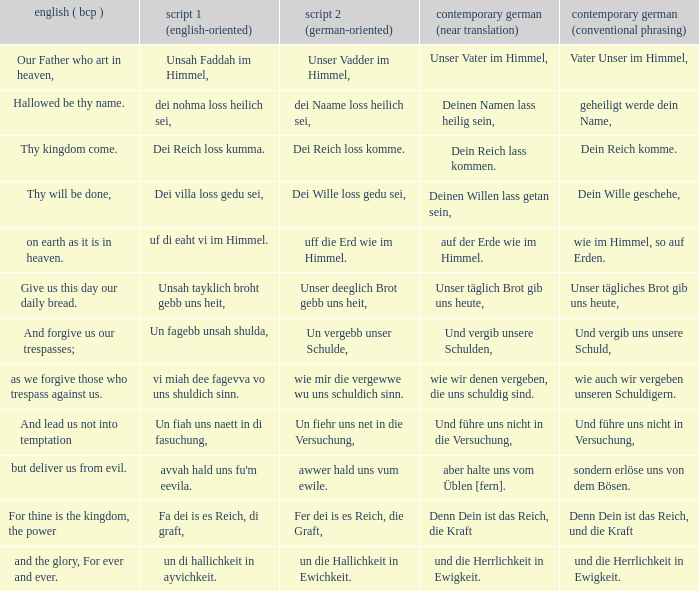What is the modern german standard wording for the german based writing system 2 phrase "wie mir die vergewwe wu uns schuldich sinn."? Wie auch wir vergeben unseren schuldigern. 